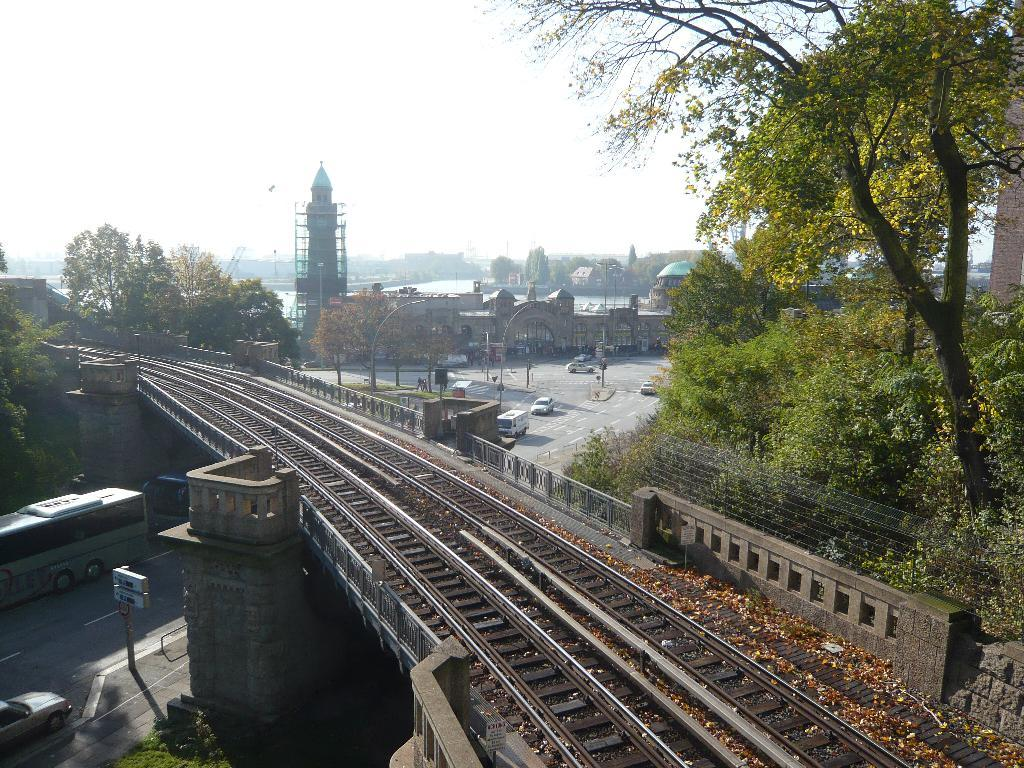What structure is the main subject of the image? There is a bridge in the image. What is on the bridge? The bridge has railway tracks on it. What can be seen under the bridge? There are vehicles under the bridge. What is visible in the background of the image? There are buildings and trees in the background of the image. What type of appliance is hanging from the bridge in the image? There is no appliance hanging from the bridge in the image; it only has railway tracks on it. What is the condition of the needle in the image? There is no needle present in the image. 